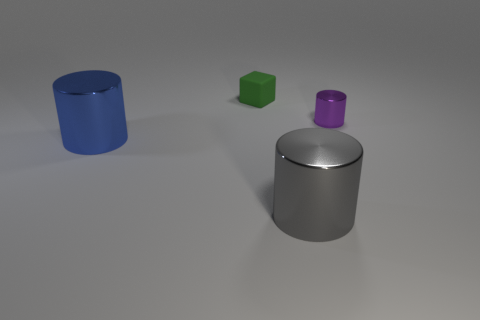There is a blue object behind the metal thing in front of the metallic cylinder left of the block; what size is it?
Make the answer very short. Large. Is there a small object that is in front of the large shiny cylinder that is right of the blue shiny object?
Your response must be concise. No. There is a tiny purple object; is its shape the same as the tiny object behind the tiny cylinder?
Your response must be concise. No. What is the color of the metal object that is left of the small matte cube?
Your response must be concise. Blue. What is the size of the thing in front of the large shiny cylinder behind the big gray thing?
Give a very brief answer. Large. Does the big blue object that is on the left side of the green thing have the same shape as the large gray shiny thing?
Keep it short and to the point. Yes. What material is the blue object that is the same shape as the purple shiny object?
Offer a very short reply. Metal. What number of things are metallic cylinders that are on the right side of the big gray cylinder or large cylinders to the right of the large blue cylinder?
Keep it short and to the point. 2. There is a tiny rubber cube; is its color the same as the tiny object on the right side of the green rubber cube?
Your response must be concise. No. There is another small object that is the same material as the gray object; what is its shape?
Your answer should be very brief. Cylinder. 